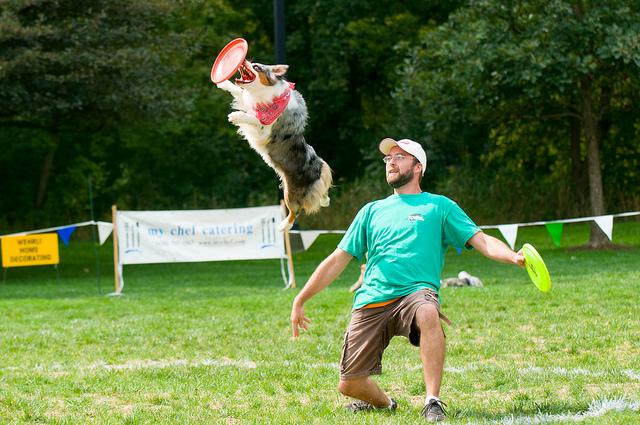What kind of service does the white sign promise?

Choices:
A) food prep
B) teeth cleaning
C) tanning
D) gardening food prep 